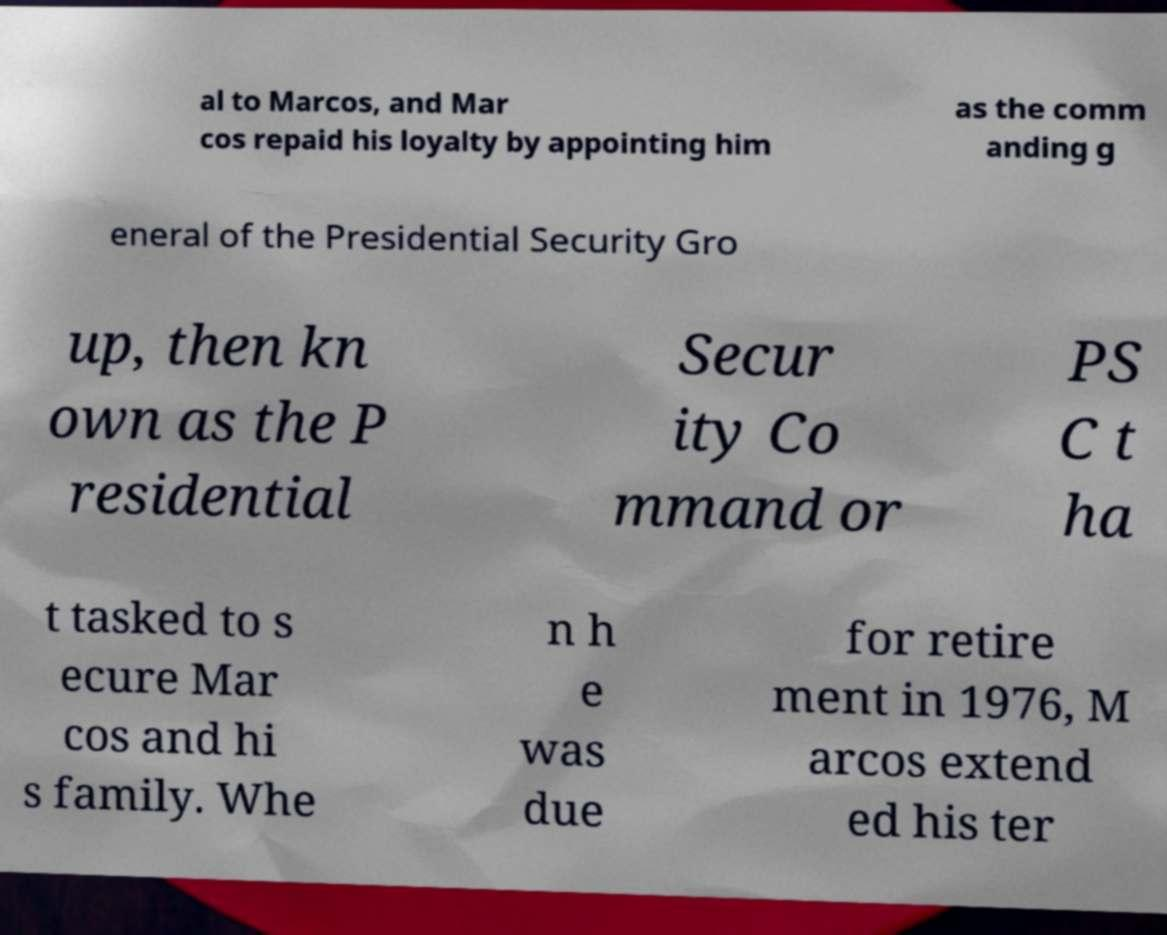I need the written content from this picture converted into text. Can you do that? al to Marcos, and Mar cos repaid his loyalty by appointing him as the comm anding g eneral of the Presidential Security Gro up, then kn own as the P residential Secur ity Co mmand or PS C t ha t tasked to s ecure Mar cos and hi s family. Whe n h e was due for retire ment in 1976, M arcos extend ed his ter 